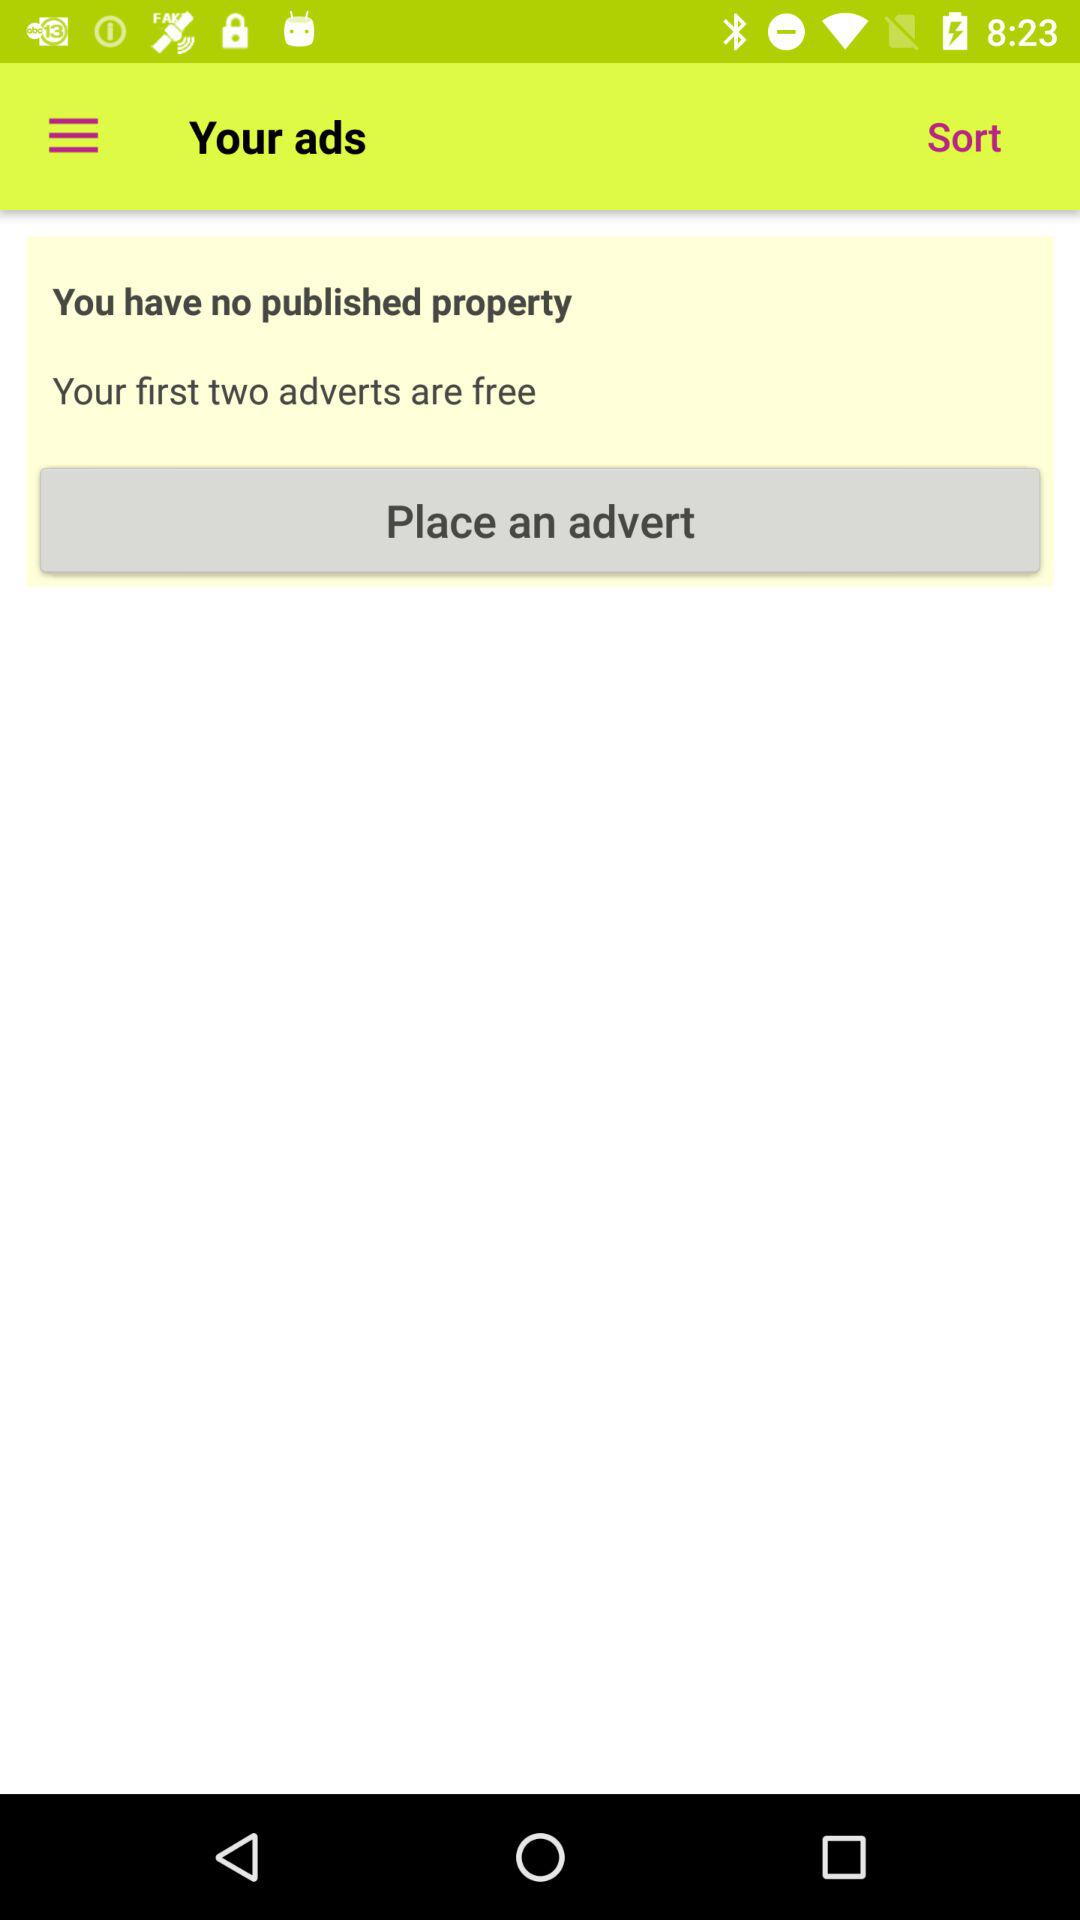How many adverts can I post for free?
Answer the question using a single word or phrase. 2 